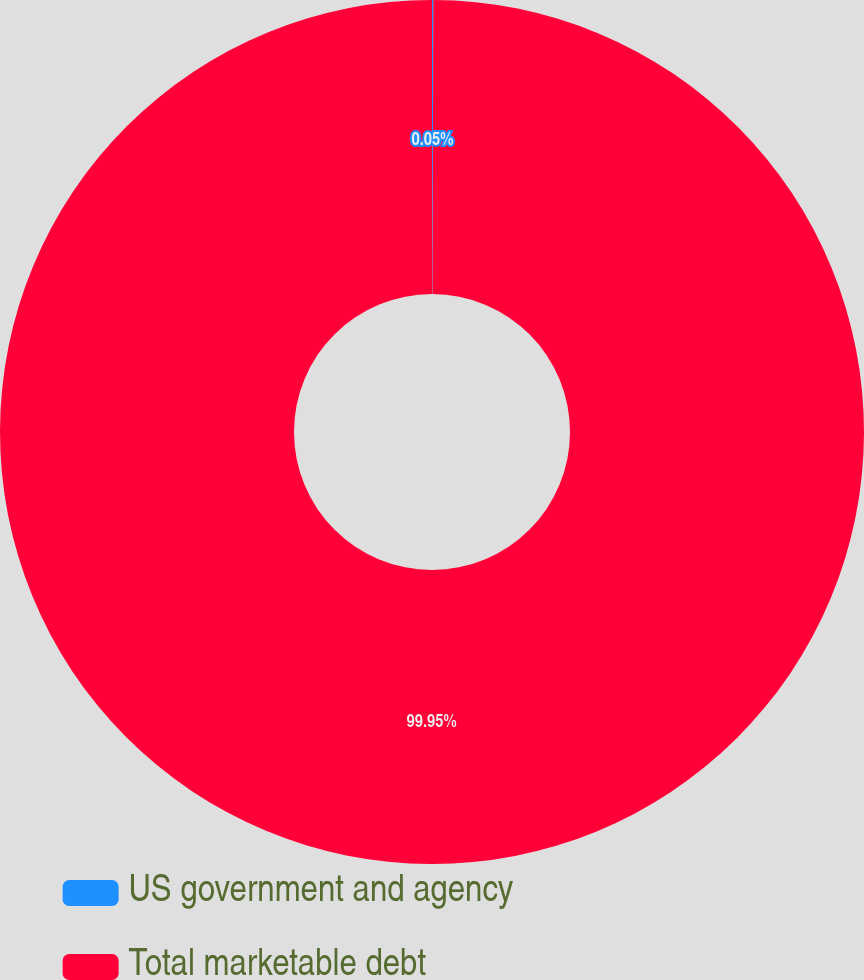Convert chart to OTSL. <chart><loc_0><loc_0><loc_500><loc_500><pie_chart><fcel>US government and agency<fcel>Total marketable debt<nl><fcel>0.05%<fcel>99.95%<nl></chart> 